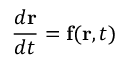<formula> <loc_0><loc_0><loc_500><loc_500>{ \frac { d r } { d t } } = f ( r , t )</formula> 